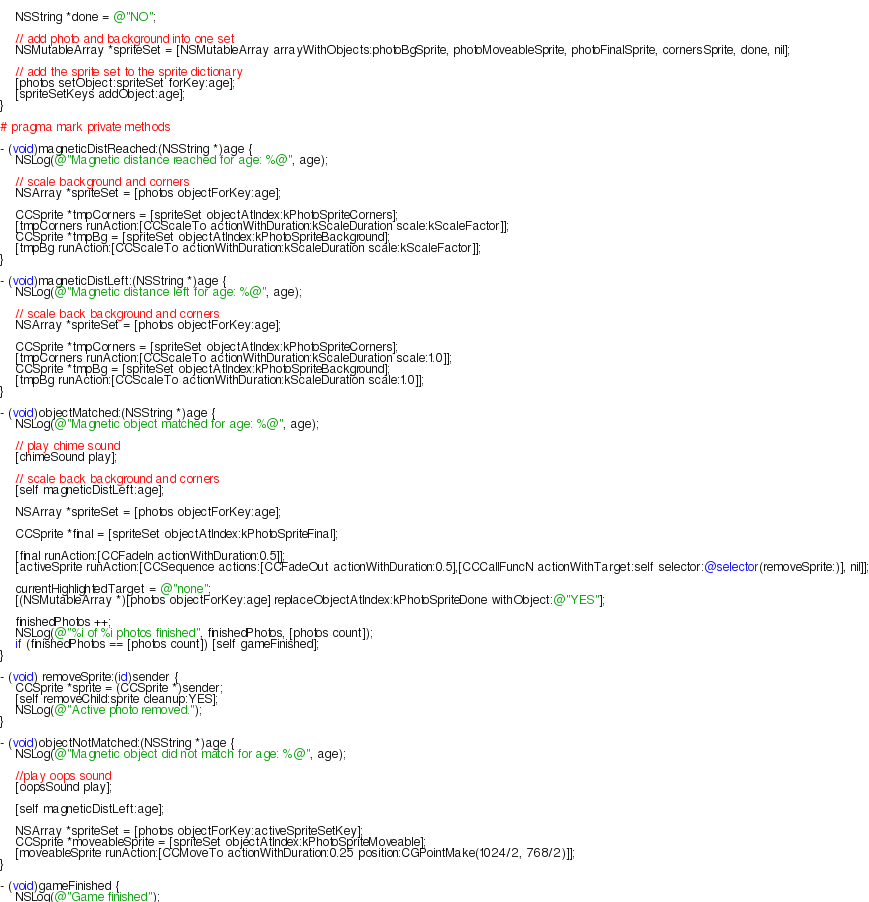Convert code to text. <code><loc_0><loc_0><loc_500><loc_500><_ObjectiveC_>    
    NSString *done = @"NO";
    
    // add photo and background into one set
    NSMutableArray *spriteSet = [NSMutableArray arrayWithObjects:photoBgSprite, photoMoveableSprite, photoFinalSprite, cornersSprite, done, nil];
    
    // add the sprite set to the sprite dictionary
    [photos setObject:spriteSet forKey:age];
    [spriteSetKeys addObject:age];
}

# pragma mark private methods

- (void)magneticDistReached:(NSString *)age {
    NSLog(@"Magnetic distance reached for age: %@", age);
    
    // scale background and corners
    NSArray *spriteSet = [photos objectForKey:age];
    
    CCSprite *tmpCorners = [spriteSet objectAtIndex:kPhotoSpriteCorners];
    [tmpCorners runAction:[CCScaleTo actionWithDuration:kScaleDuration scale:kScaleFactor]];
    CCSprite *tmpBg = [spriteSet objectAtIndex:kPhotoSpriteBackground];
    [tmpBg runAction:[CCScaleTo actionWithDuration:kScaleDuration scale:kScaleFactor]];
}

- (void)magneticDistLeft:(NSString *)age {
    NSLog(@"Magnetic distance left for age: %@", age);
    
    // scale back background and corners
    NSArray *spriteSet = [photos objectForKey:age];
    
    CCSprite *tmpCorners = [spriteSet objectAtIndex:kPhotoSpriteCorners];
    [tmpCorners runAction:[CCScaleTo actionWithDuration:kScaleDuration scale:1.0]];
    CCSprite *tmpBg = [spriteSet objectAtIndex:kPhotoSpriteBackground];
    [tmpBg runAction:[CCScaleTo actionWithDuration:kScaleDuration scale:1.0]];
}

- (void)objectMatched:(NSString *)age {
    NSLog(@"Magnetic object matched for age: %@", age);

    // play chime sound
    [chimeSound play];
    
    // scale back background and corners
    [self magneticDistLeft:age];
    
    NSArray *spriteSet = [photos objectForKey:age];
    
    CCSprite *final = [spriteSet objectAtIndex:kPhotoSpriteFinal];
    
    [final runAction:[CCFadeIn actionWithDuration:0.5]];
    [activeSprite runAction:[CCSequence actions:[CCFadeOut actionWithDuration:0.5],[CCCallFuncN actionWithTarget:self selector:@selector(removeSprite:)], nil]];
    
    currentHighlightedTarget = @"none";  
    [(NSMutableArray *)[photos objectForKey:age] replaceObjectAtIndex:kPhotoSpriteDone withObject:@"YES"];
    
    finishedPhotos ++;
    NSLog(@"%i of %i photos finished", finishedPhotos, [photos count]);
    if (finishedPhotos == [photos count]) [self gameFinished];
}

- (void) removeSprite:(id)sender {
    CCSprite *sprite = (CCSprite *)sender;
    [self removeChild:sprite cleanup:YES];
    NSLog(@"Active photo removed.");
}

- (void)objectNotMatched:(NSString *)age {
    NSLog(@"Magnetic object did not match for age: %@", age);
    
    //play oops sound
    [oopsSound play];  
    
    [self magneticDistLeft:age];
    
    NSArray *spriteSet = [photos objectForKey:activeSpriteSetKey];
    CCSprite *moveableSprite = [spriteSet objectAtIndex:kPhotoSpriteMoveable];
    [moveableSprite runAction:[CCMoveTo actionWithDuration:0.25 position:CGPointMake(1024/2, 768/2)]];
}

- (void)gameFinished {
    NSLog(@"Game finished");</code> 